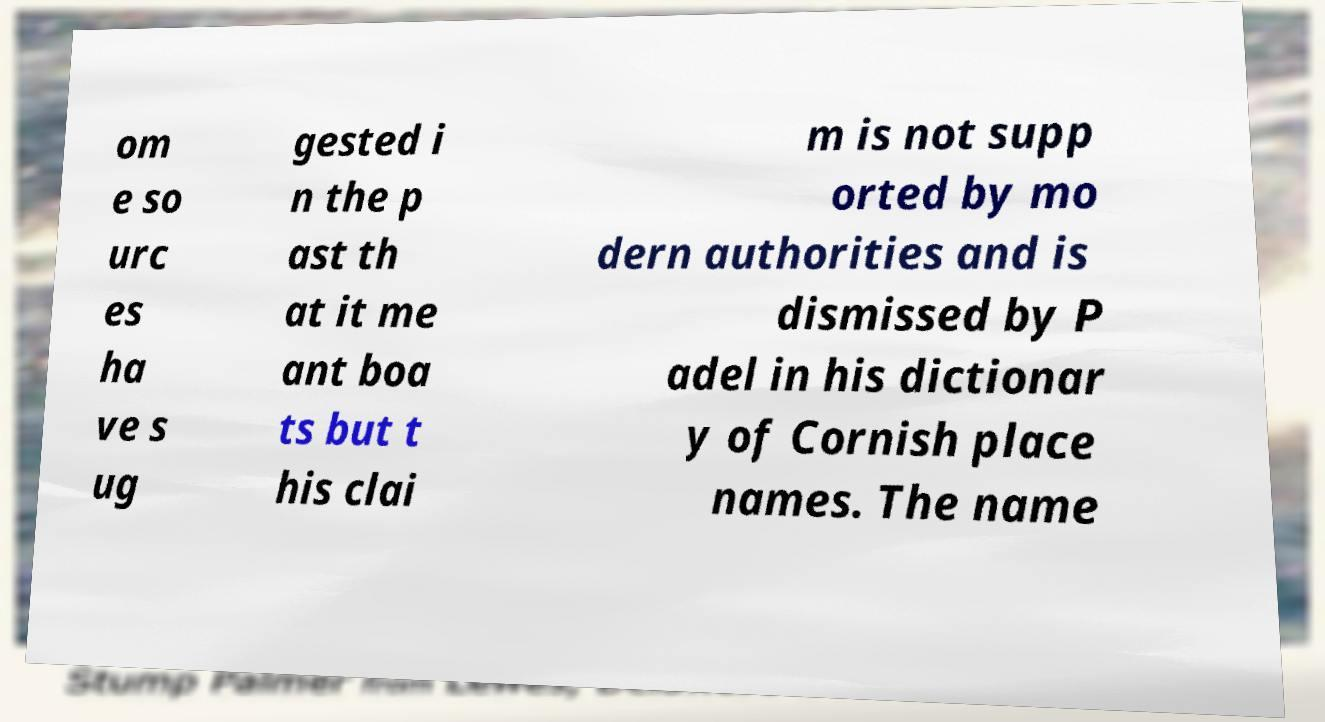For documentation purposes, I need the text within this image transcribed. Could you provide that? om e so urc es ha ve s ug gested i n the p ast th at it me ant boa ts but t his clai m is not supp orted by mo dern authorities and is dismissed by P adel in his dictionar y of Cornish place names. The name 